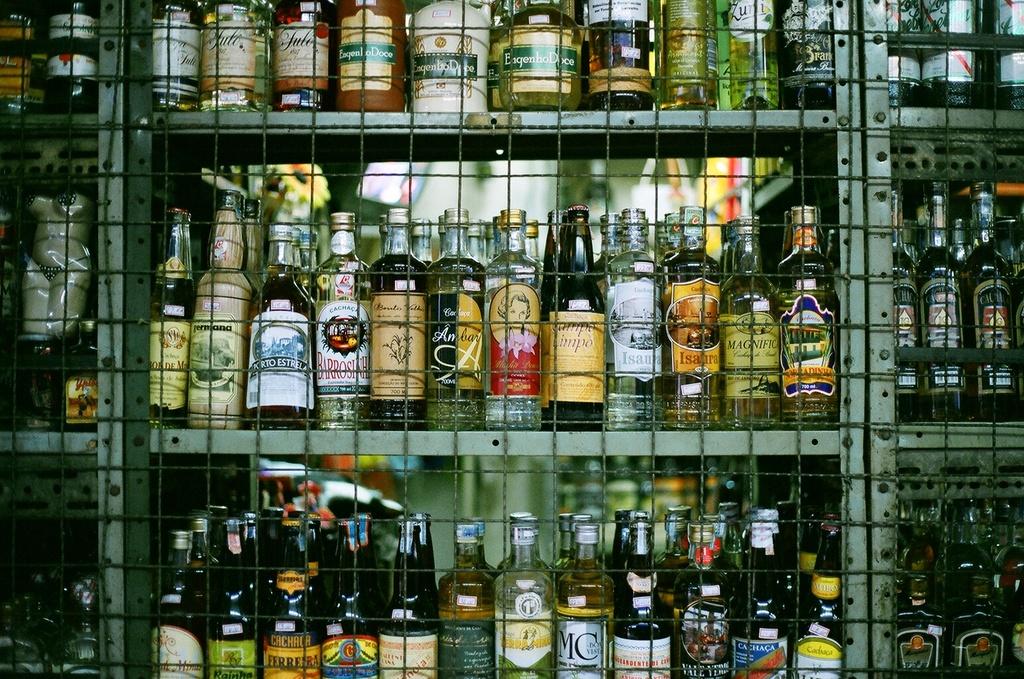What is one of the brands?
Provide a short and direct response. Mc. 